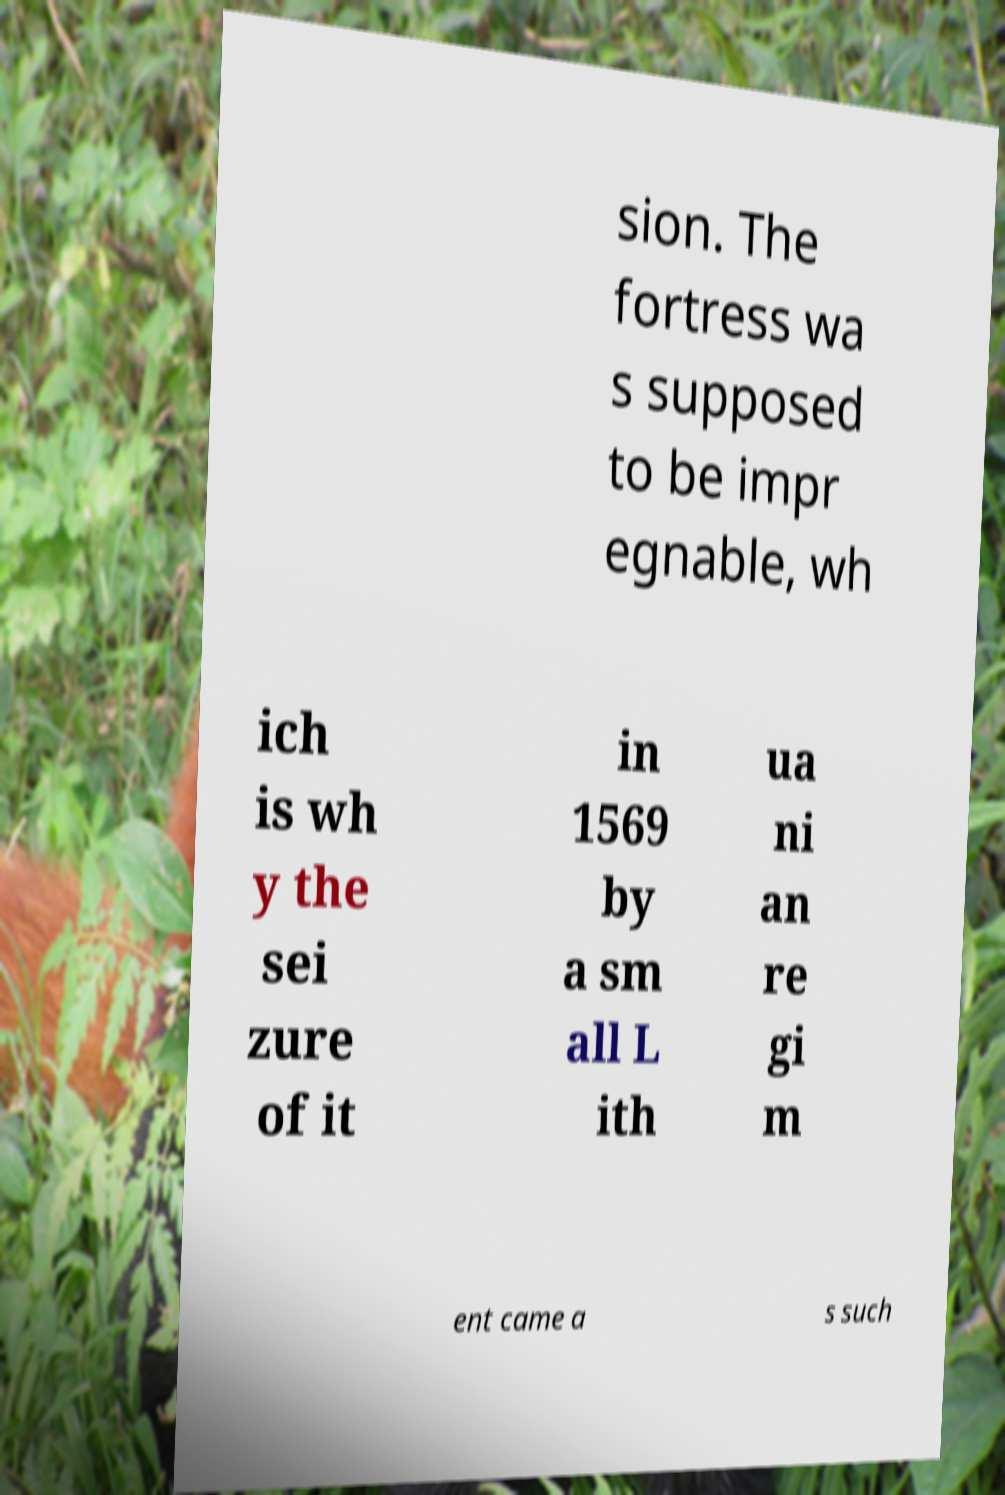For documentation purposes, I need the text within this image transcribed. Could you provide that? sion. The fortress wa s supposed to be impr egnable, wh ich is wh y the sei zure of it in 1569 by a sm all L ith ua ni an re gi m ent came a s such 